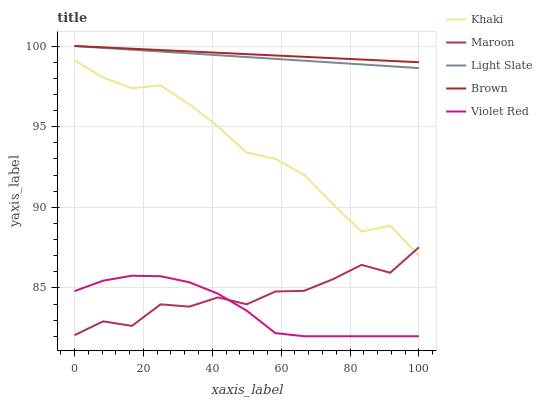Does Violet Red have the minimum area under the curve?
Answer yes or no. Yes. Does Brown have the maximum area under the curve?
Answer yes or no. Yes. Does Brown have the minimum area under the curve?
Answer yes or no. No. Does Violet Red have the maximum area under the curve?
Answer yes or no. No. Is Light Slate the smoothest?
Answer yes or no. Yes. Is Maroon the roughest?
Answer yes or no. Yes. Is Brown the smoothest?
Answer yes or no. No. Is Brown the roughest?
Answer yes or no. No. Does Violet Red have the lowest value?
Answer yes or no. Yes. Does Brown have the lowest value?
Answer yes or no. No. Does Brown have the highest value?
Answer yes or no. Yes. Does Violet Red have the highest value?
Answer yes or no. No. Is Khaki less than Light Slate?
Answer yes or no. Yes. Is Light Slate greater than Maroon?
Answer yes or no. Yes. Does Maroon intersect Violet Red?
Answer yes or no. Yes. Is Maroon less than Violet Red?
Answer yes or no. No. Is Maroon greater than Violet Red?
Answer yes or no. No. Does Khaki intersect Light Slate?
Answer yes or no. No. 